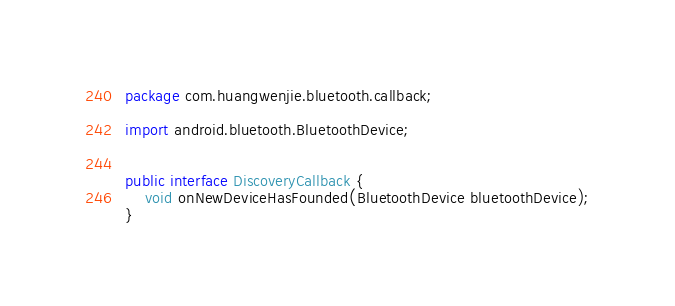<code> <loc_0><loc_0><loc_500><loc_500><_Java_>package com.huangwenjie.bluetooth.callback;

import android.bluetooth.BluetoothDevice;


public interface DiscoveryCallback {
    void onNewDeviceHasFounded(BluetoothDevice bluetoothDevice);
}
</code> 